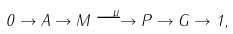Convert formula to latex. <formula><loc_0><loc_0><loc_500><loc_500>0 \to A \to M \stackrel { \mu } { \longrightarrow } P \to G \to 1 ,</formula> 